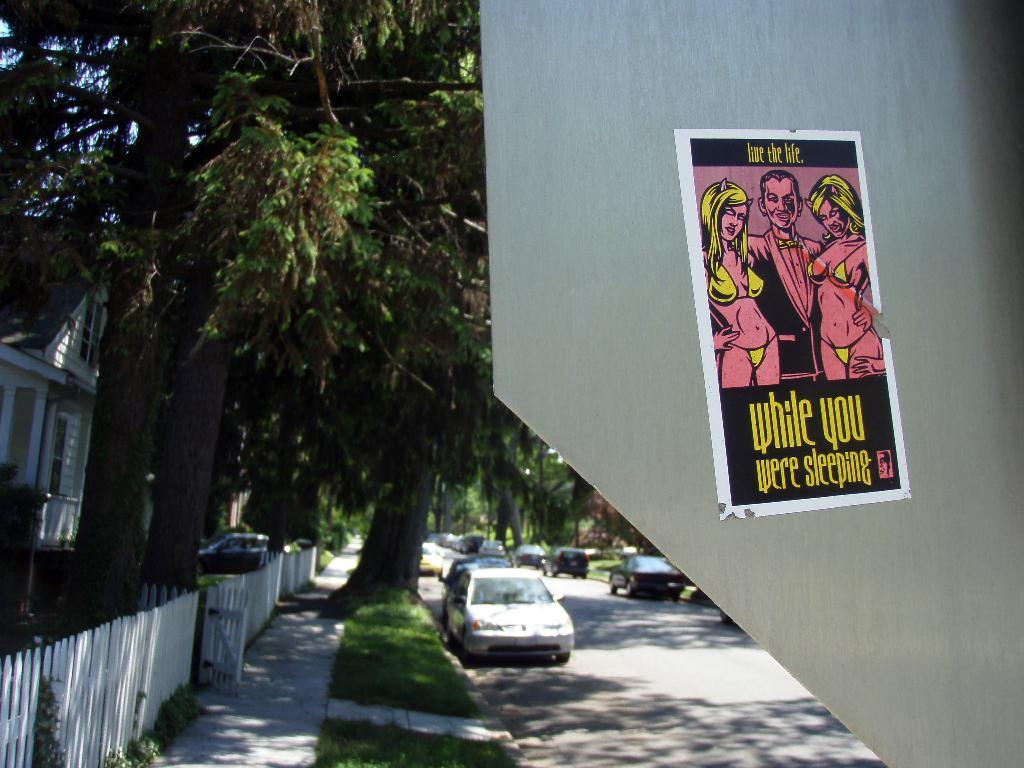What can be seen on the road in the image? There are cars on the road in the image. What else is present in the image besides the cars? There is a poster, grass, plants, a fence, a house, and trees in the background of the image. Can you describe the vegetation in the image? There is grass and plants visible in the image, as well as trees in the background. What type of structure is in the image? There is a house in the image. What is the purpose of the fence in the image? The purpose of the fence in the image is not explicitly stated, but it may serve as a boundary or barrier. Can you hear the baby crying in the image? There is no baby or crying sound present in the image. What is burning in the image? There is no fire or burning object present in the image. 